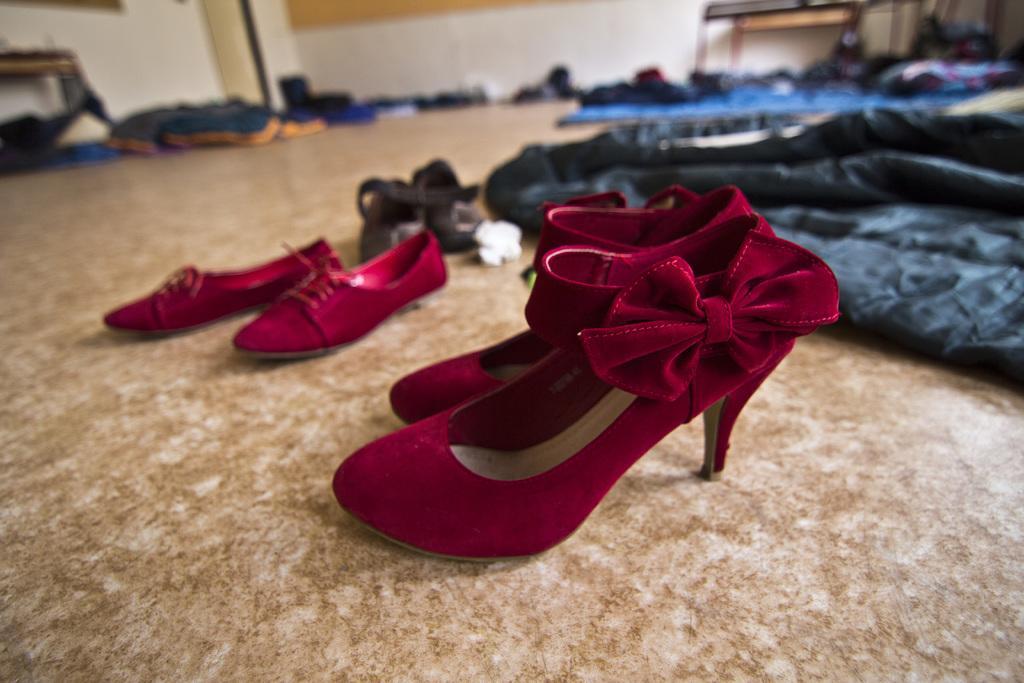Describe this image in one or two sentences. In this image we can see some footwear, clothes, some other objects on the floor, there we can also see tables, wall and a door. 